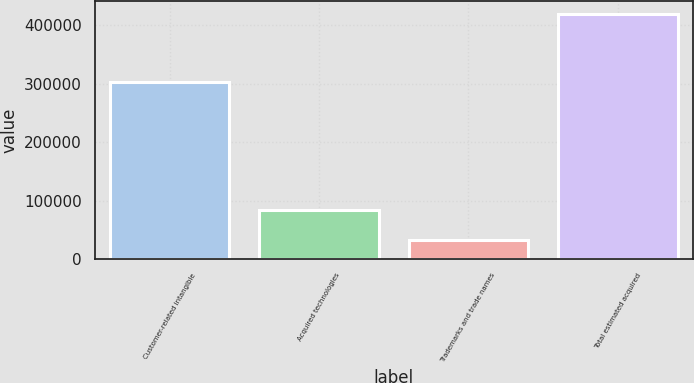Convert chart. <chart><loc_0><loc_0><loc_500><loc_500><bar_chart><fcel>Customer-related intangible<fcel>Acquired technologies<fcel>Trademarks and trade names<fcel>Total estimated acquired<nl><fcel>303100<fcel>83700<fcel>32700<fcel>419500<nl></chart> 